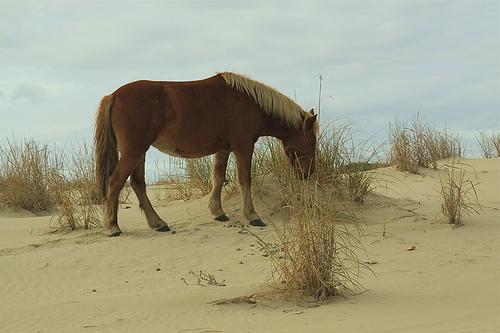How many horses are there?
Give a very brief answer. 1. 